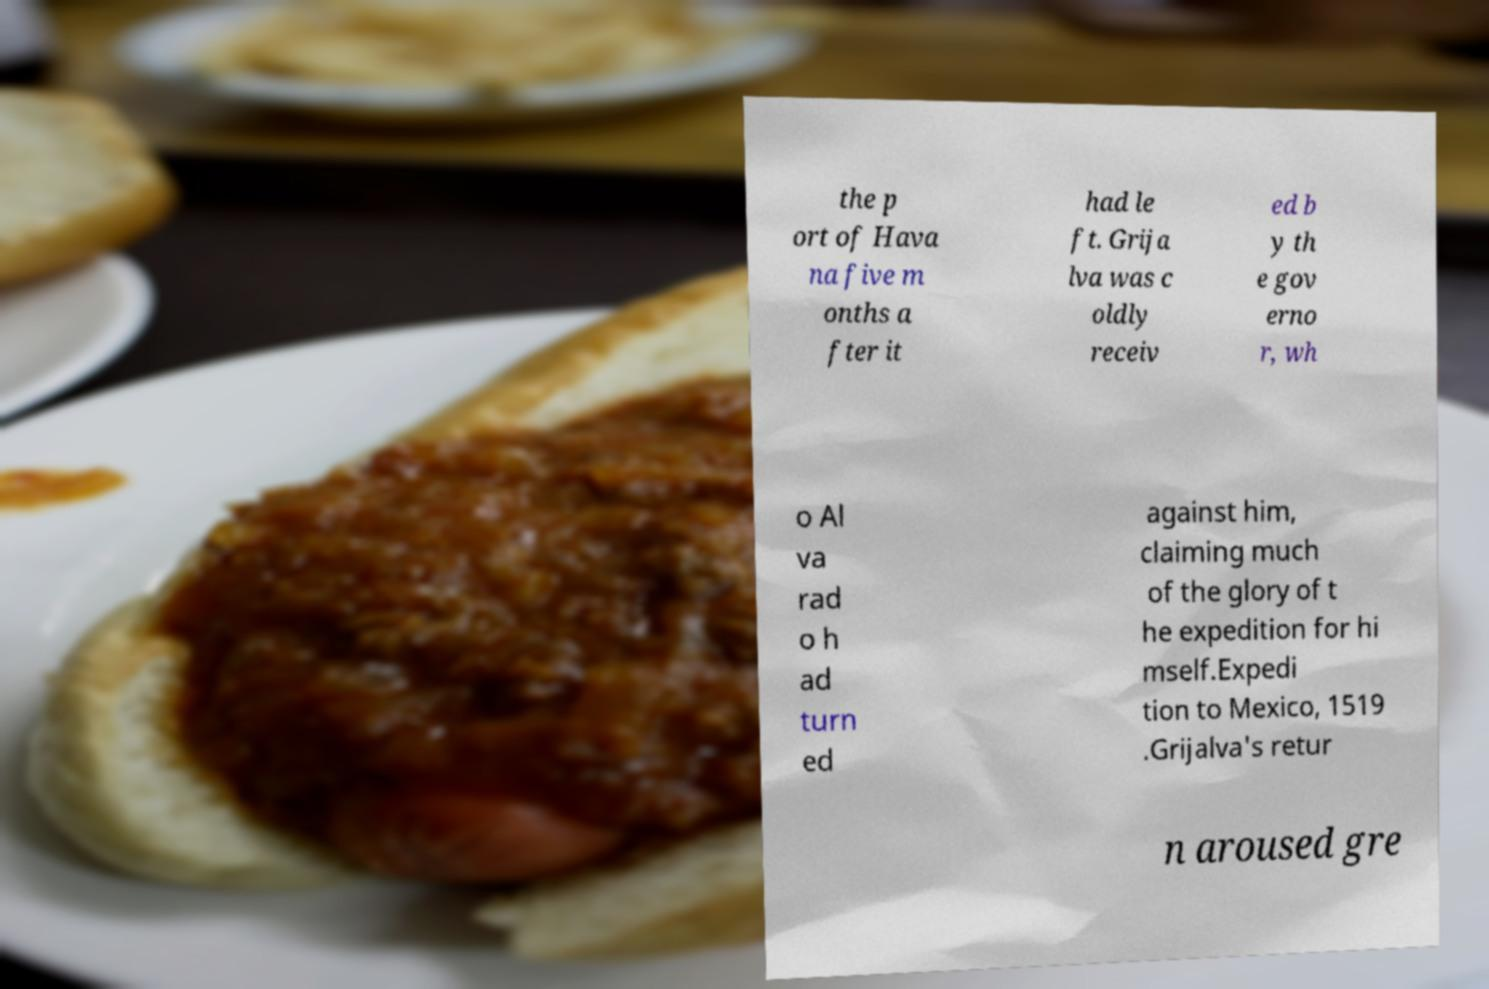Please identify and transcribe the text found in this image. the p ort of Hava na five m onths a fter it had le ft. Grija lva was c oldly receiv ed b y th e gov erno r, wh o Al va rad o h ad turn ed against him, claiming much of the glory of t he expedition for hi mself.Expedi tion to Mexico, 1519 .Grijalva's retur n aroused gre 